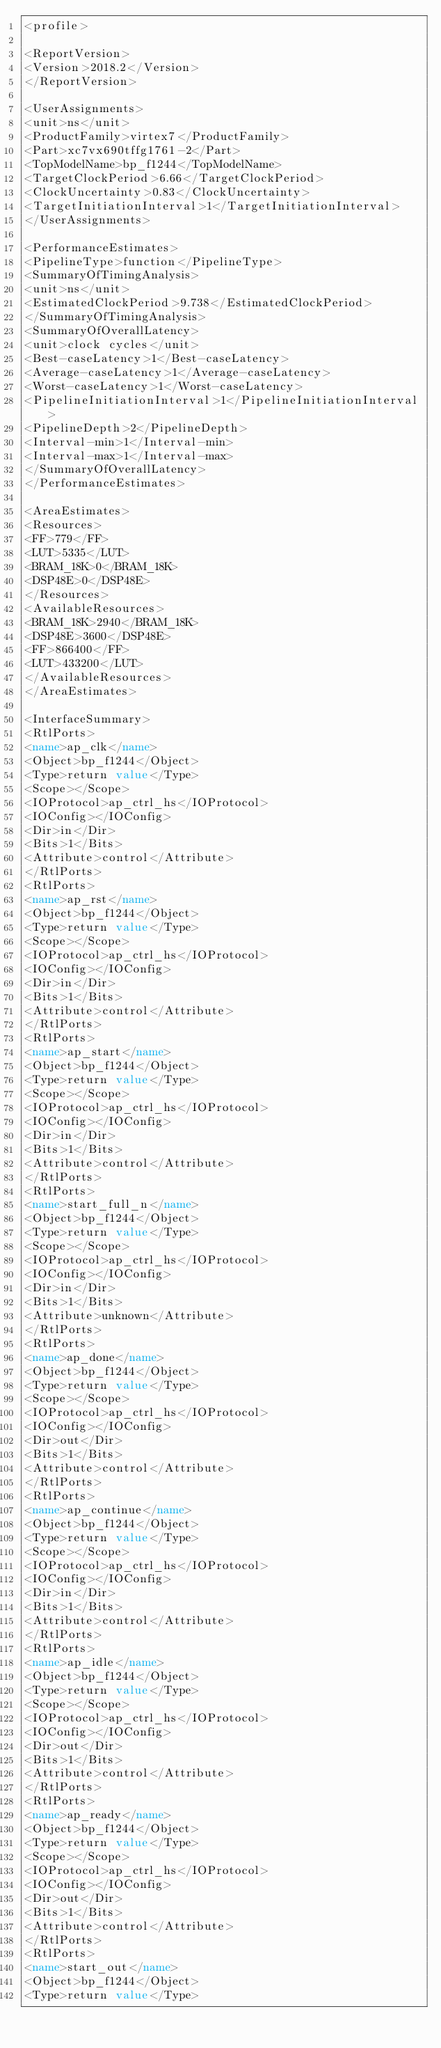Convert code to text. <code><loc_0><loc_0><loc_500><loc_500><_XML_><profile>

<ReportVersion>
<Version>2018.2</Version>
</ReportVersion>

<UserAssignments>
<unit>ns</unit>
<ProductFamily>virtex7</ProductFamily>
<Part>xc7vx690tffg1761-2</Part>
<TopModelName>bp_f1244</TopModelName>
<TargetClockPeriod>6.66</TargetClockPeriod>
<ClockUncertainty>0.83</ClockUncertainty>
<TargetInitiationInterval>1</TargetInitiationInterval>
</UserAssignments>

<PerformanceEstimates>
<PipelineType>function</PipelineType>
<SummaryOfTimingAnalysis>
<unit>ns</unit>
<EstimatedClockPeriod>9.738</EstimatedClockPeriod>
</SummaryOfTimingAnalysis>
<SummaryOfOverallLatency>
<unit>clock cycles</unit>
<Best-caseLatency>1</Best-caseLatency>
<Average-caseLatency>1</Average-caseLatency>
<Worst-caseLatency>1</Worst-caseLatency>
<PipelineInitiationInterval>1</PipelineInitiationInterval>
<PipelineDepth>2</PipelineDepth>
<Interval-min>1</Interval-min>
<Interval-max>1</Interval-max>
</SummaryOfOverallLatency>
</PerformanceEstimates>

<AreaEstimates>
<Resources>
<FF>779</FF>
<LUT>5335</LUT>
<BRAM_18K>0</BRAM_18K>
<DSP48E>0</DSP48E>
</Resources>
<AvailableResources>
<BRAM_18K>2940</BRAM_18K>
<DSP48E>3600</DSP48E>
<FF>866400</FF>
<LUT>433200</LUT>
</AvailableResources>
</AreaEstimates>

<InterfaceSummary>
<RtlPorts>
<name>ap_clk</name>
<Object>bp_f1244</Object>
<Type>return value</Type>
<Scope></Scope>
<IOProtocol>ap_ctrl_hs</IOProtocol>
<IOConfig></IOConfig>
<Dir>in</Dir>
<Bits>1</Bits>
<Attribute>control</Attribute>
</RtlPorts>
<RtlPorts>
<name>ap_rst</name>
<Object>bp_f1244</Object>
<Type>return value</Type>
<Scope></Scope>
<IOProtocol>ap_ctrl_hs</IOProtocol>
<IOConfig></IOConfig>
<Dir>in</Dir>
<Bits>1</Bits>
<Attribute>control</Attribute>
</RtlPorts>
<RtlPorts>
<name>ap_start</name>
<Object>bp_f1244</Object>
<Type>return value</Type>
<Scope></Scope>
<IOProtocol>ap_ctrl_hs</IOProtocol>
<IOConfig></IOConfig>
<Dir>in</Dir>
<Bits>1</Bits>
<Attribute>control</Attribute>
</RtlPorts>
<RtlPorts>
<name>start_full_n</name>
<Object>bp_f1244</Object>
<Type>return value</Type>
<Scope></Scope>
<IOProtocol>ap_ctrl_hs</IOProtocol>
<IOConfig></IOConfig>
<Dir>in</Dir>
<Bits>1</Bits>
<Attribute>unknown</Attribute>
</RtlPorts>
<RtlPorts>
<name>ap_done</name>
<Object>bp_f1244</Object>
<Type>return value</Type>
<Scope></Scope>
<IOProtocol>ap_ctrl_hs</IOProtocol>
<IOConfig></IOConfig>
<Dir>out</Dir>
<Bits>1</Bits>
<Attribute>control</Attribute>
</RtlPorts>
<RtlPorts>
<name>ap_continue</name>
<Object>bp_f1244</Object>
<Type>return value</Type>
<Scope></Scope>
<IOProtocol>ap_ctrl_hs</IOProtocol>
<IOConfig></IOConfig>
<Dir>in</Dir>
<Bits>1</Bits>
<Attribute>control</Attribute>
</RtlPorts>
<RtlPorts>
<name>ap_idle</name>
<Object>bp_f1244</Object>
<Type>return value</Type>
<Scope></Scope>
<IOProtocol>ap_ctrl_hs</IOProtocol>
<IOConfig></IOConfig>
<Dir>out</Dir>
<Bits>1</Bits>
<Attribute>control</Attribute>
</RtlPorts>
<RtlPorts>
<name>ap_ready</name>
<Object>bp_f1244</Object>
<Type>return value</Type>
<Scope></Scope>
<IOProtocol>ap_ctrl_hs</IOProtocol>
<IOConfig></IOConfig>
<Dir>out</Dir>
<Bits>1</Bits>
<Attribute>control</Attribute>
</RtlPorts>
<RtlPorts>
<name>start_out</name>
<Object>bp_f1244</Object>
<Type>return value</Type></code> 